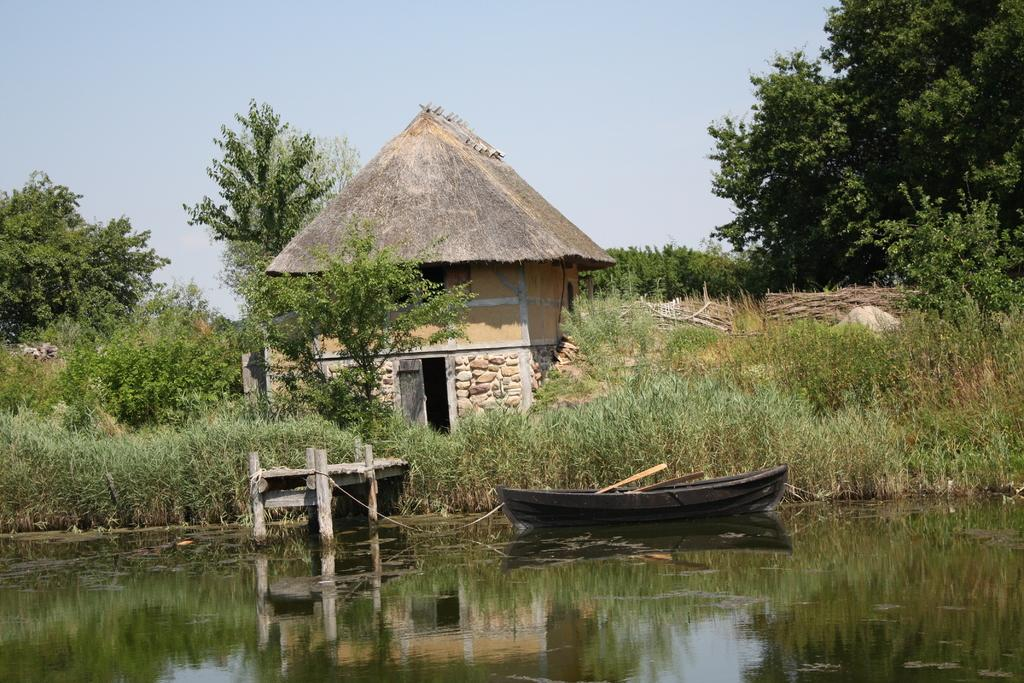What can be seen in the sky in the image? The sky is visible in the image. What type of natural vegetation is present in the image? There are trees in the image. What type of structure is in the image? There is a hut in the image. What part of the hut is visible in the image? There is a door in the image. What type of plants are in the image? There are plants in the image. What type of material is present in the image? There is a rope in the image. What type of arrangement is visible in the image? There are rows in the image. What type of watercraft is in the image? There is a boat in the image. What type of body of water is in the image? There is a lake in the image. What type of construction material is in the image? There are piles of wooden sticks in the image. Can you see the grandmother knotting the rope in the image? There is no grandmother or knotting action present in the image. What type of flag is flying over the hut in the image? There is no flag present in the image. 